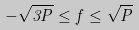<formula> <loc_0><loc_0><loc_500><loc_500>- \sqrt { 3 P } \leq f \leq \sqrt { P }</formula> 